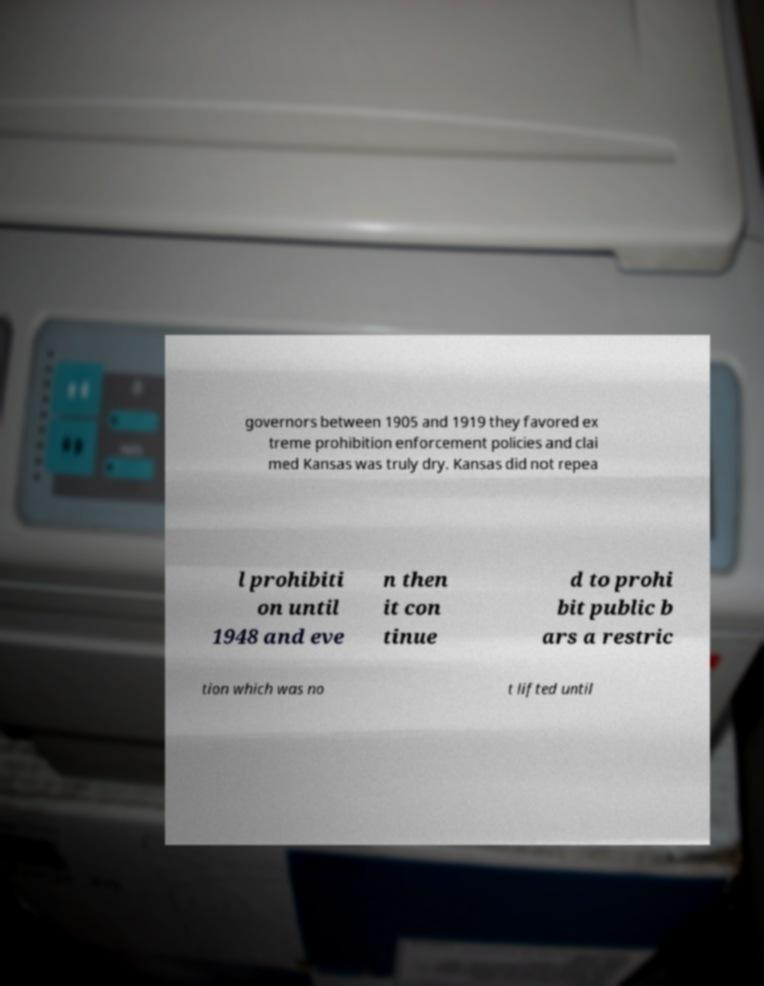Can you accurately transcribe the text from the provided image for me? governors between 1905 and 1919 they favored ex treme prohibition enforcement policies and clai med Kansas was truly dry. Kansas did not repea l prohibiti on until 1948 and eve n then it con tinue d to prohi bit public b ars a restric tion which was no t lifted until 